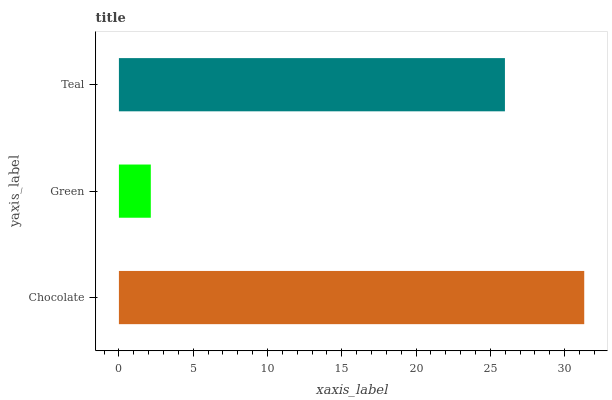Is Green the minimum?
Answer yes or no. Yes. Is Chocolate the maximum?
Answer yes or no. Yes. Is Teal the minimum?
Answer yes or no. No. Is Teal the maximum?
Answer yes or no. No. Is Teal greater than Green?
Answer yes or no. Yes. Is Green less than Teal?
Answer yes or no. Yes. Is Green greater than Teal?
Answer yes or no. No. Is Teal less than Green?
Answer yes or no. No. Is Teal the high median?
Answer yes or no. Yes. Is Teal the low median?
Answer yes or no. Yes. Is Chocolate the high median?
Answer yes or no. No. Is Chocolate the low median?
Answer yes or no. No. 